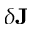Convert formula to latex. <formula><loc_0><loc_0><loc_500><loc_500>\delta J</formula> 